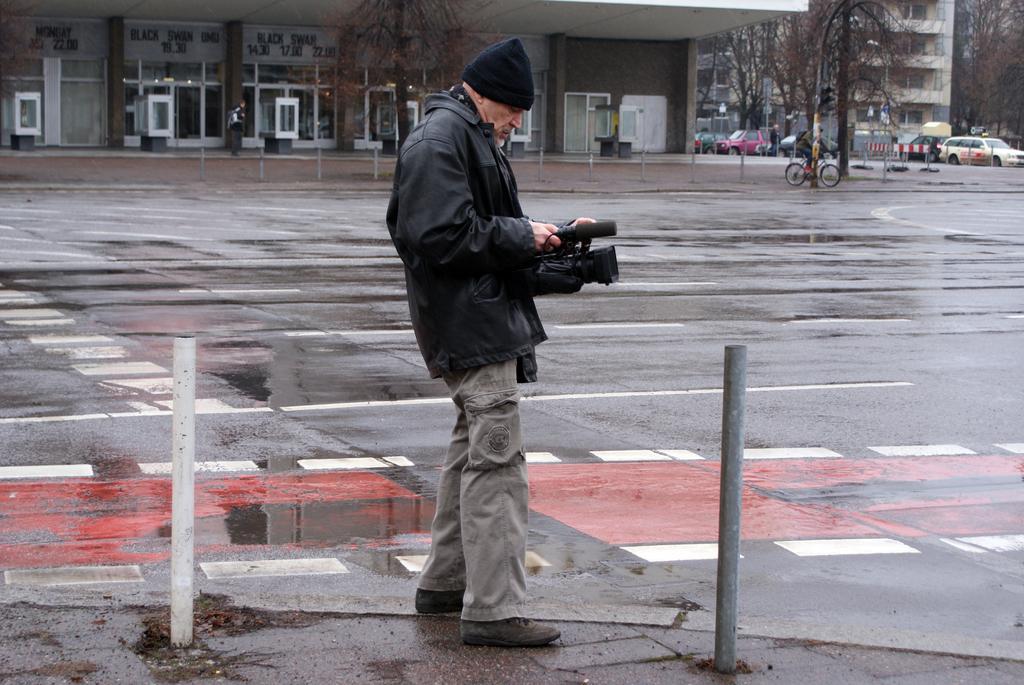How would you summarize this image in a sentence or two? In this image in the front there are poles and there is a person standing and holding a camera in his hand. In the background there are buildings, trees, vehicles and there are persons and there are poles. 